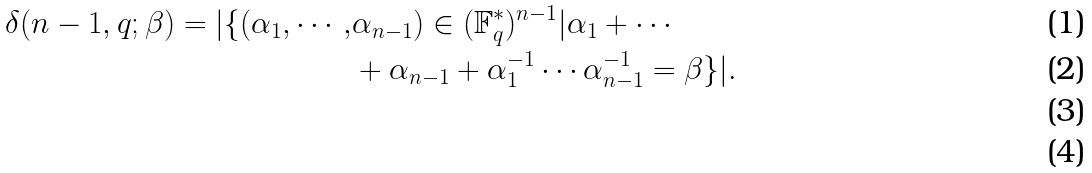Convert formula to latex. <formula><loc_0><loc_0><loc_500><loc_500>\delta ( n - 1 , q ; \beta ) = | \{ ( \alpha _ { 1 } , \cdots , & \alpha _ { n - 1 } ) \in ( \mathbb { F } _ { q } ^ { * } ) ^ { n - 1 } | \alpha _ { 1 } + \cdots \\ & + \alpha _ { n - 1 } + \alpha _ { 1 } ^ { - 1 } \cdots \alpha _ { n - 1 } ^ { - 1 } = \beta \} | . \\ \\</formula> 